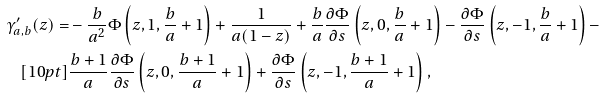Convert formula to latex. <formula><loc_0><loc_0><loc_500><loc_500>\gamma ^ { \prime } _ { a , b } ( z ) = & - \frac { b } { a ^ { 2 } } \Phi \left ( z , 1 , \frac { b } { a } + 1 \right ) + \frac { 1 } { a ( 1 - z ) } + \frac { b } { a } \frac { \partial \Phi } { \partial s } \left ( z , 0 , \frac { b } { a } + 1 \right ) - \frac { \partial \Phi } { \partial s } \left ( z , - 1 , \frac { b } { a } + 1 \right ) - \\ [ 1 0 p t ] & \frac { b + 1 } { a } \frac { \partial \Phi } { \partial s } \left ( z , 0 , \frac { b + 1 } { a } + 1 \right ) + \frac { \partial \Phi } { \partial s } \left ( z , - 1 , \frac { b + 1 } { a } + 1 \right ) ,</formula> 